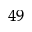<formula> <loc_0><loc_0><loc_500><loc_500>^ { 4 9 }</formula> 